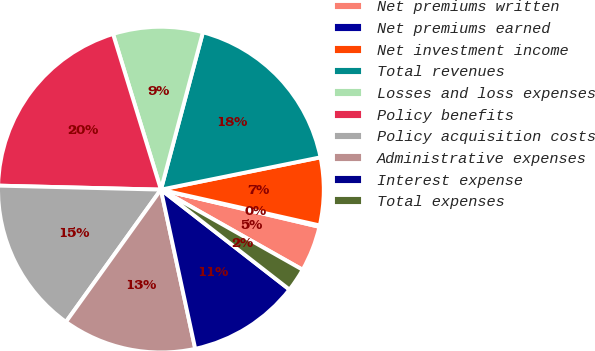<chart> <loc_0><loc_0><loc_500><loc_500><pie_chart><fcel>Net premiums written<fcel>Net premiums earned<fcel>Net investment income<fcel>Total revenues<fcel>Losses and loss expenses<fcel>Policy benefits<fcel>Policy acquisition costs<fcel>Administrative expenses<fcel>Interest expense<fcel>Total expenses<nl><fcel>4.52%<fcel>0.14%<fcel>6.71%<fcel>17.67%<fcel>8.9%<fcel>19.86%<fcel>15.48%<fcel>13.29%<fcel>11.1%<fcel>2.33%<nl></chart> 